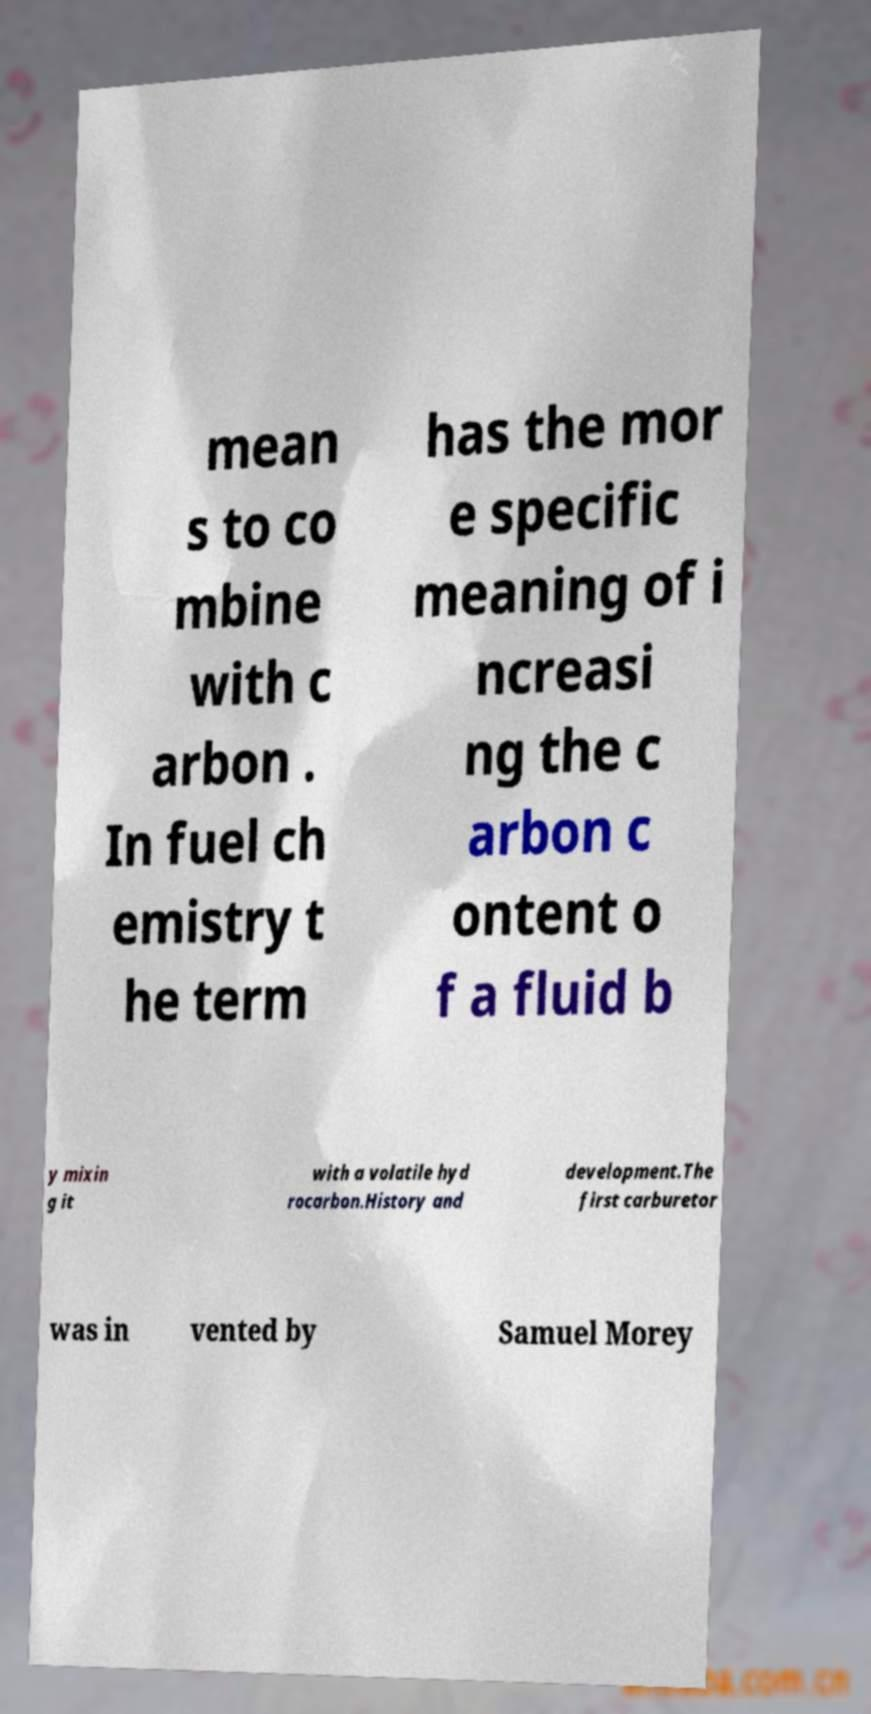Can you read and provide the text displayed in the image?This photo seems to have some interesting text. Can you extract and type it out for me? mean s to co mbine with c arbon . In fuel ch emistry t he term has the mor e specific meaning of i ncreasi ng the c arbon c ontent o f a fluid b y mixin g it with a volatile hyd rocarbon.History and development.The first carburetor was in vented by Samuel Morey 